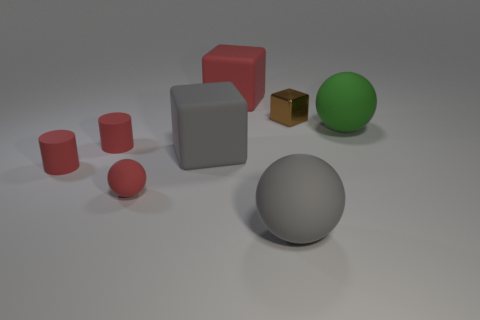What is the thing that is both behind the green matte sphere and on the right side of the gray sphere made of?
Make the answer very short. Metal. There is a brown block that is the same size as the red ball; what material is it?
Offer a very short reply. Metal. Is there a large gray object that is on the right side of the matte cube in front of the large block behind the brown shiny cube?
Your answer should be very brief. Yes. What is the material of the red thing that is the same shape as the brown metallic thing?
Your answer should be very brief. Rubber. Are there any other things that have the same material as the brown object?
Your answer should be compact. No. What number of cylinders are brown objects or green things?
Make the answer very short. 0. Does the thing behind the tiny metallic block have the same size as the thing that is right of the tiny cube?
Ensure brevity in your answer.  Yes. What material is the cylinder behind the gray matte object left of the gray ball?
Your answer should be compact. Rubber. Are there fewer green matte things that are in front of the red rubber ball than large yellow objects?
Your response must be concise. No. What is the shape of the large green object that is made of the same material as the big gray ball?
Your answer should be compact. Sphere. 